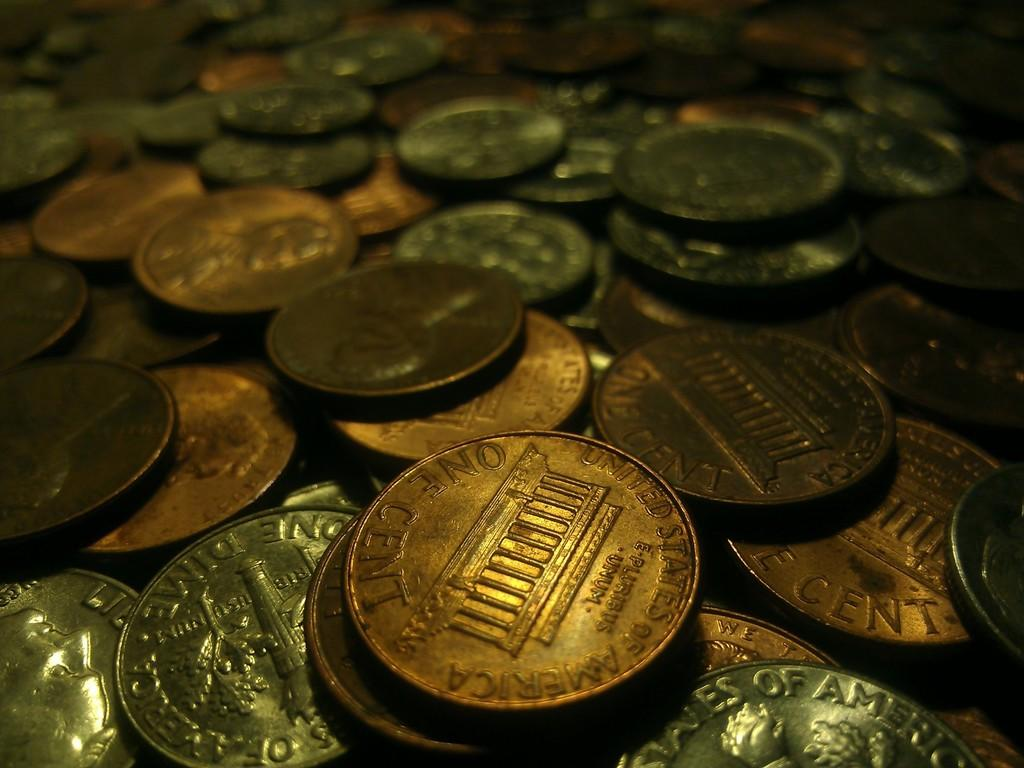<image>
Present a compact description of the photo's key features. Various United States pennies and dimes are piled together. 